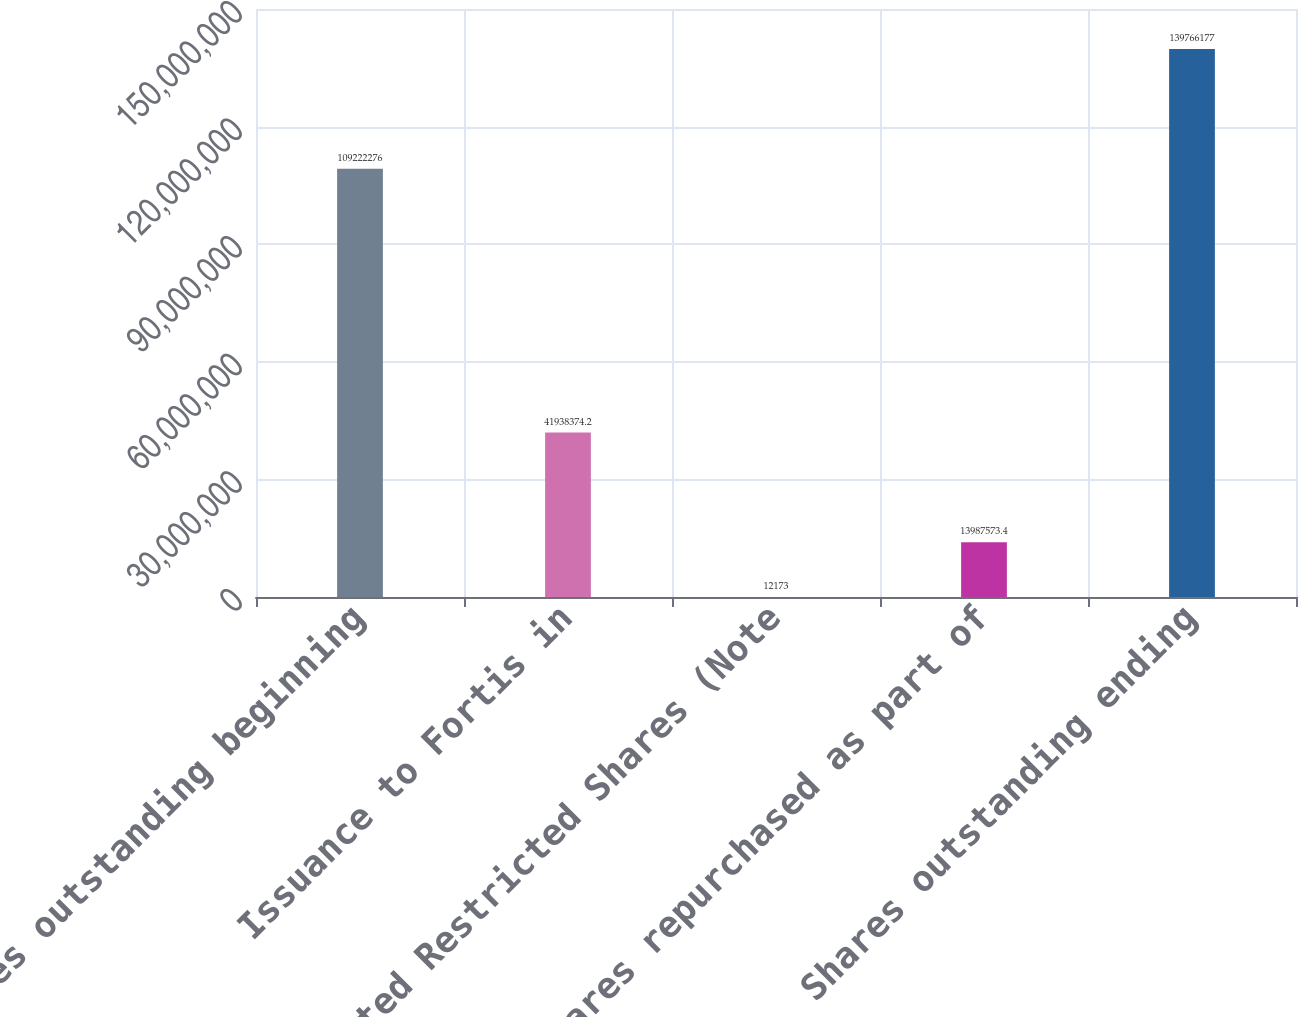Convert chart to OTSL. <chart><loc_0><loc_0><loc_500><loc_500><bar_chart><fcel>Shares outstanding beginning<fcel>Issuance to Fortis in<fcel>Vested Restricted Shares (Note<fcel>Shares repurchased as part of<fcel>Shares outstanding ending<nl><fcel>1.09222e+08<fcel>4.19384e+07<fcel>12173<fcel>1.39876e+07<fcel>1.39766e+08<nl></chart> 